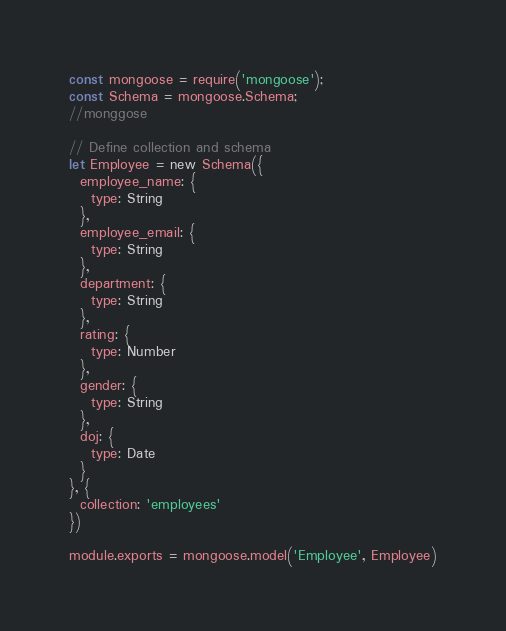Convert code to text. <code><loc_0><loc_0><loc_500><loc_500><_JavaScript_>const mongoose = require('mongoose');
const Schema = mongoose.Schema;
//monggose

// Define collection and schema
let Employee = new Schema({
  employee_name: {
    type: String
  },
  employee_email: {
    type: String
  },
  department: {
    type: String
  },
  rating: {
    type: Number
  },
  gender: {
    type: String
  },
  doj: {
    type: Date
  }
}, {
  collection: 'employees'
})

module.exports = mongoose.model('Employee', Employee)</code> 